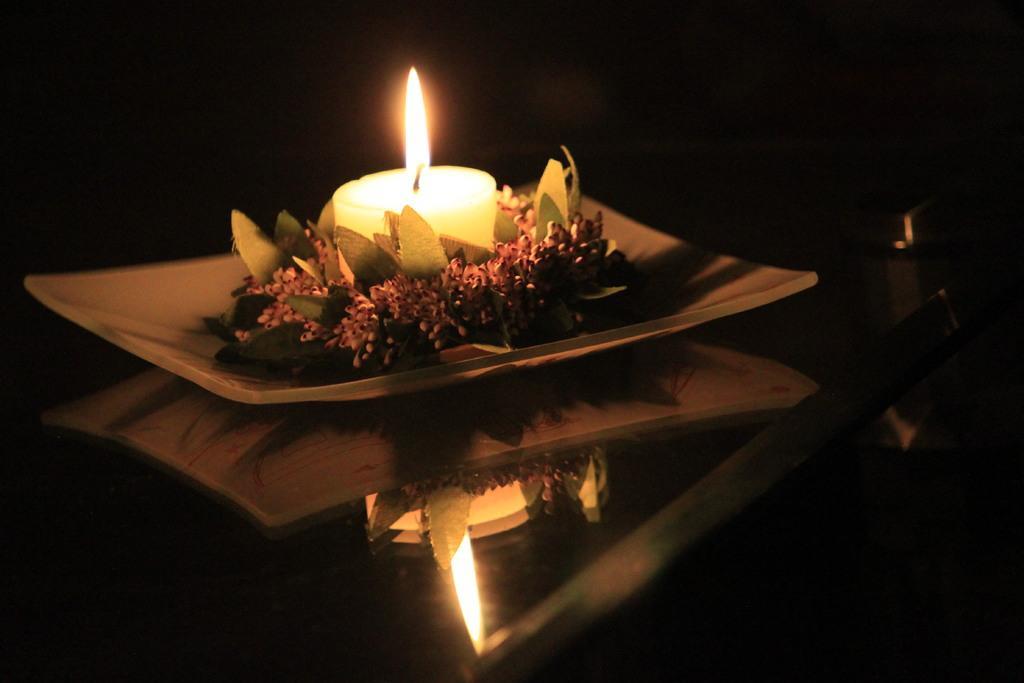How would you summarize this image in a sentence or two? In this image there is a plate. On the plate there are leaves, flowers and a candle. At the bottom there is the reflection of the plate and a candle. There is flame on the candle. The background is dark. 